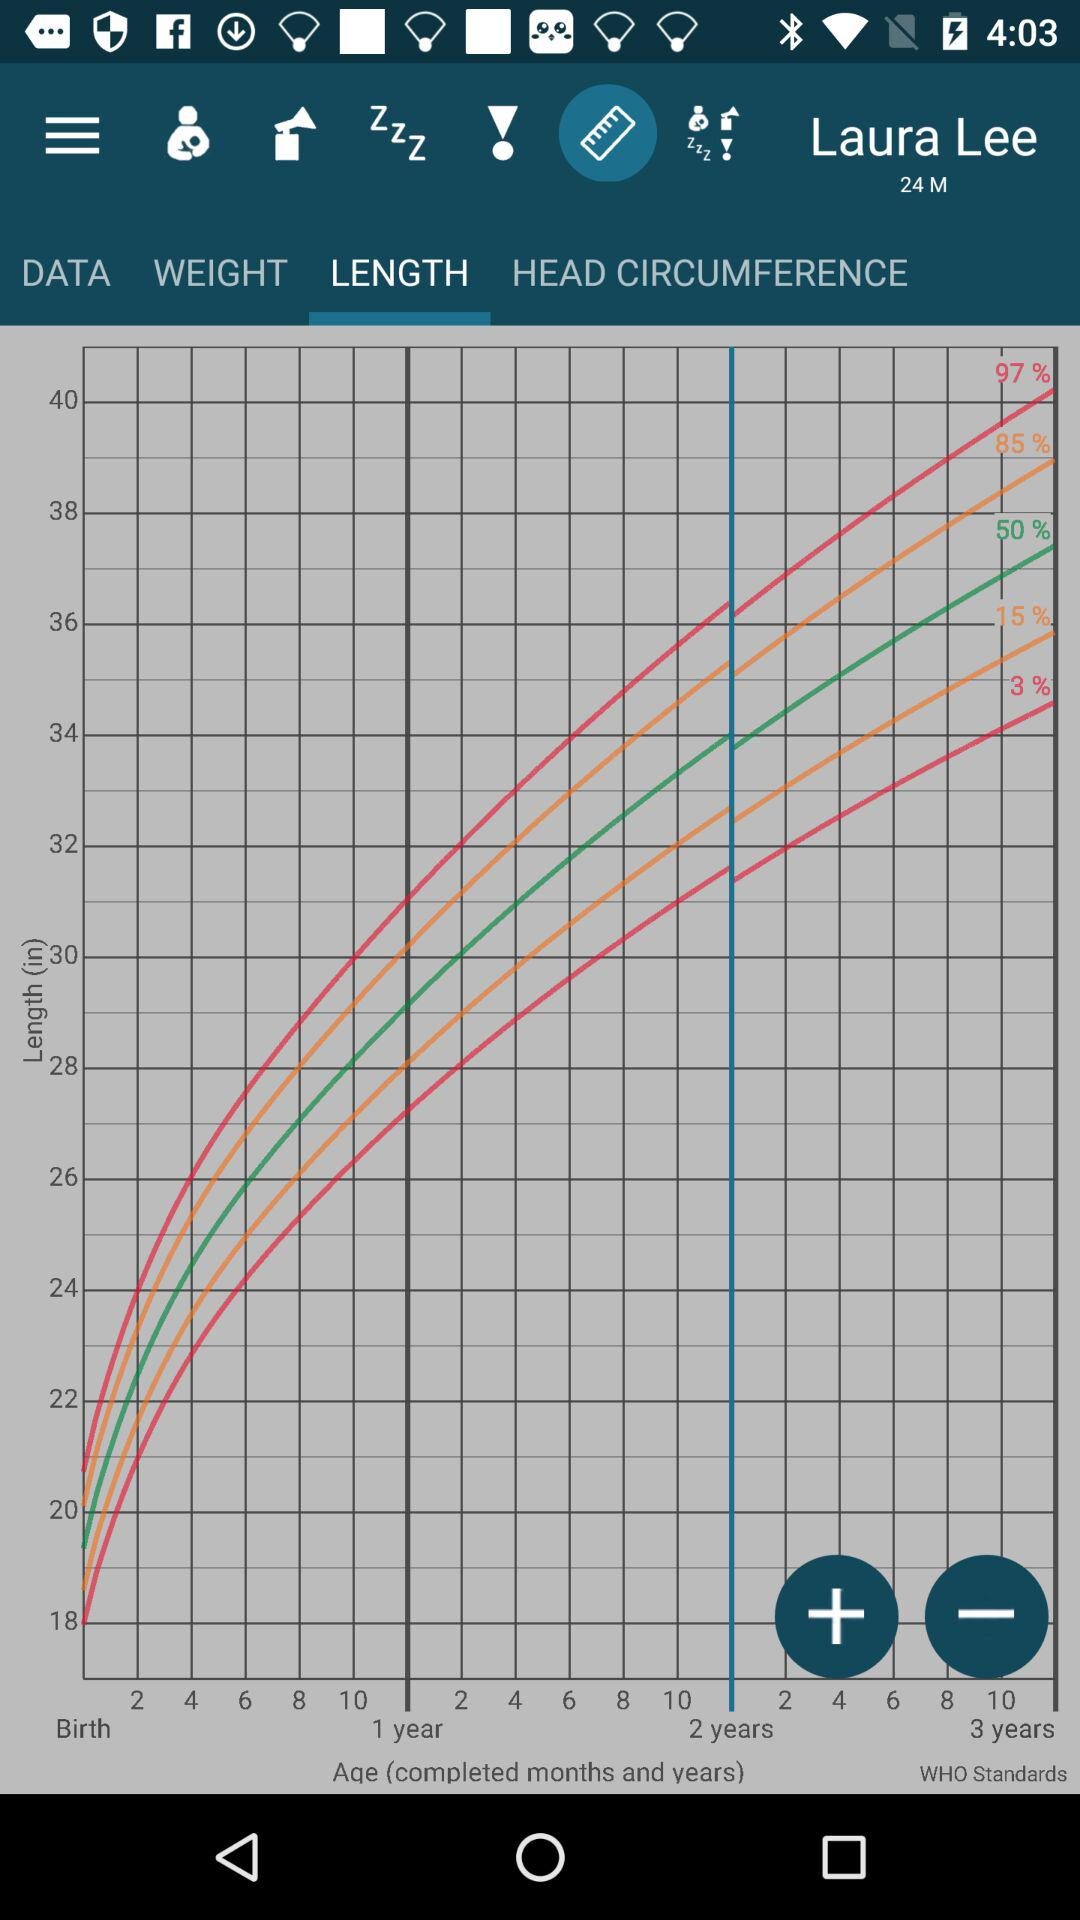Which tab are we on? You are on the "LENGTH" tab. 